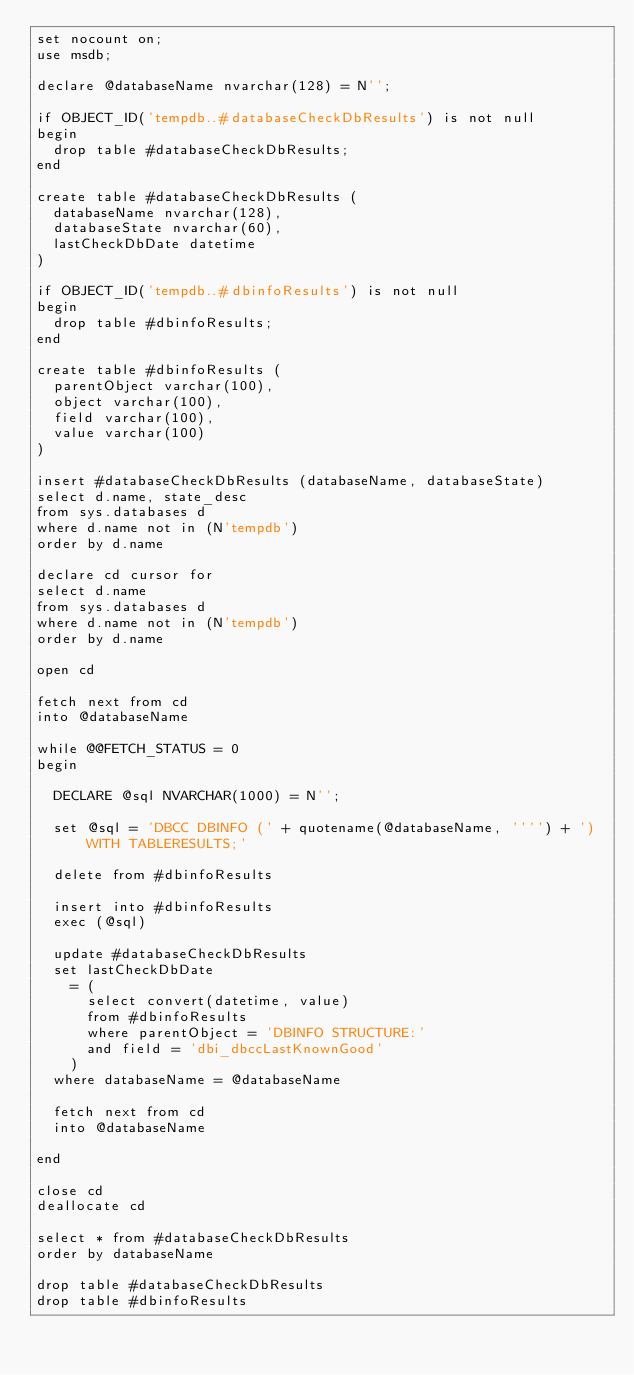Convert code to text. <code><loc_0><loc_0><loc_500><loc_500><_SQL_>set nocount on;
use msdb;

declare @databaseName nvarchar(128) = N'';

if OBJECT_ID('tempdb..#databaseCheckDbResults') is not null
begin
	drop table #databaseCheckDbResults;
end

create table #databaseCheckDbResults (
	databaseName nvarchar(128),
	databaseState nvarchar(60),
	lastCheckDbDate datetime
)

if OBJECT_ID('tempdb..#dbinfoResults') is not null
begin
	drop table #dbinfoResults;
end

create table #dbinfoResults (
	parentObject varchar(100),
	object varchar(100),
	field varchar(100),
	value varchar(100)
)

insert #databaseCheckDbResults (databaseName, databaseState)
select d.name, state_desc
from sys.databases d
where d.name not in (N'tempdb')
order by d.name

declare cd cursor for
select d.name
from sys.databases d
where d.name not in (N'tempdb')
order by d.name

open cd

fetch next from cd
into @databaseName

while @@FETCH_STATUS = 0
begin

	DECLARE @sql NVARCHAR(1000) = N'';

	set @sql = 'DBCC DBINFO (' + quotename(@databaseName, '''') + ') WITH TABLERESULTS;'

	delete from #dbinfoResults

	insert into #dbinfoResults
	exec (@sql)

	update #databaseCheckDbResults
	set lastCheckDbDate
		= (
			select convert(datetime, value)
			from #dbinfoResults
			where parentObject = 'DBINFO STRUCTURE:'
			and field = 'dbi_dbccLastKnownGood'
		)
	where databaseName = @databaseName

	fetch next from cd
	into @databaseName

end

close cd
deallocate cd

select * from #databaseCheckDbResults
order by databaseName

drop table #databaseCheckDbResults
drop table #dbinfoResults
</code> 